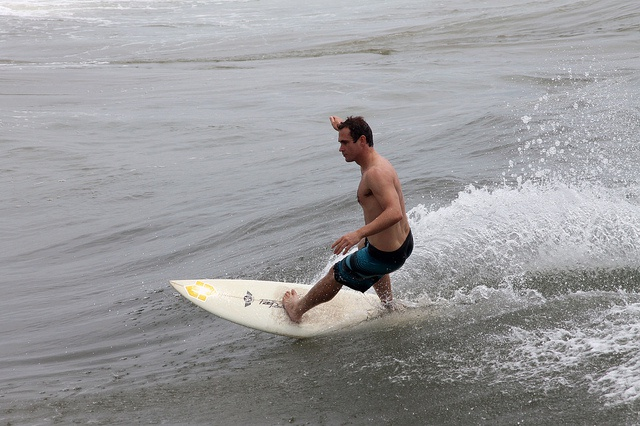Describe the objects in this image and their specific colors. I can see people in lightgray, black, maroon, and brown tones and surfboard in lightgray, ivory, and darkgray tones in this image. 